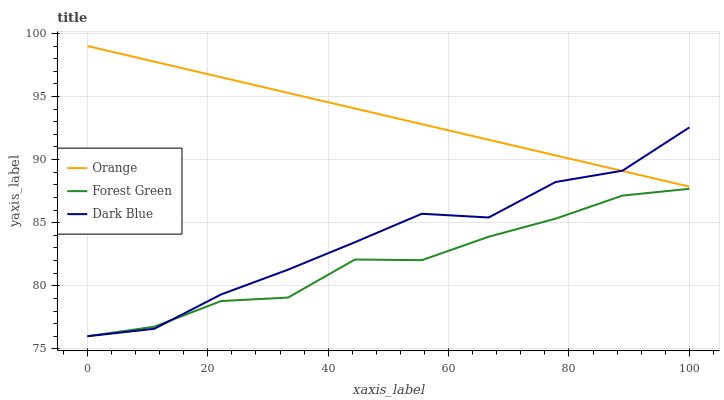Does Forest Green have the minimum area under the curve?
Answer yes or no. Yes. Does Orange have the maximum area under the curve?
Answer yes or no. Yes. Does Dark Blue have the minimum area under the curve?
Answer yes or no. No. Does Dark Blue have the maximum area under the curve?
Answer yes or no. No. Is Orange the smoothest?
Answer yes or no. Yes. Is Dark Blue the roughest?
Answer yes or no. Yes. Is Forest Green the smoothest?
Answer yes or no. No. Is Forest Green the roughest?
Answer yes or no. No. Does Dark Blue have the lowest value?
Answer yes or no. Yes. Does Orange have the highest value?
Answer yes or no. Yes. Does Dark Blue have the highest value?
Answer yes or no. No. Is Forest Green less than Orange?
Answer yes or no. Yes. Is Orange greater than Forest Green?
Answer yes or no. Yes. Does Orange intersect Dark Blue?
Answer yes or no. Yes. Is Orange less than Dark Blue?
Answer yes or no. No. Is Orange greater than Dark Blue?
Answer yes or no. No. Does Forest Green intersect Orange?
Answer yes or no. No. 